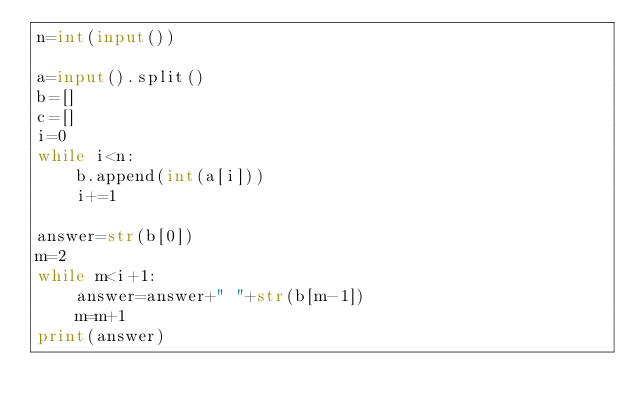<code> <loc_0><loc_0><loc_500><loc_500><_Python_>n=int(input())

a=input().split()
b=[]
c=[]
i=0
while i<n:
    b.append(int(a[i]))
    i+=1

answer=str(b[0])
m=2
while m<i+1:
    answer=answer+" "+str(b[m-1])
    m=m+1
print(answer)

</code> 